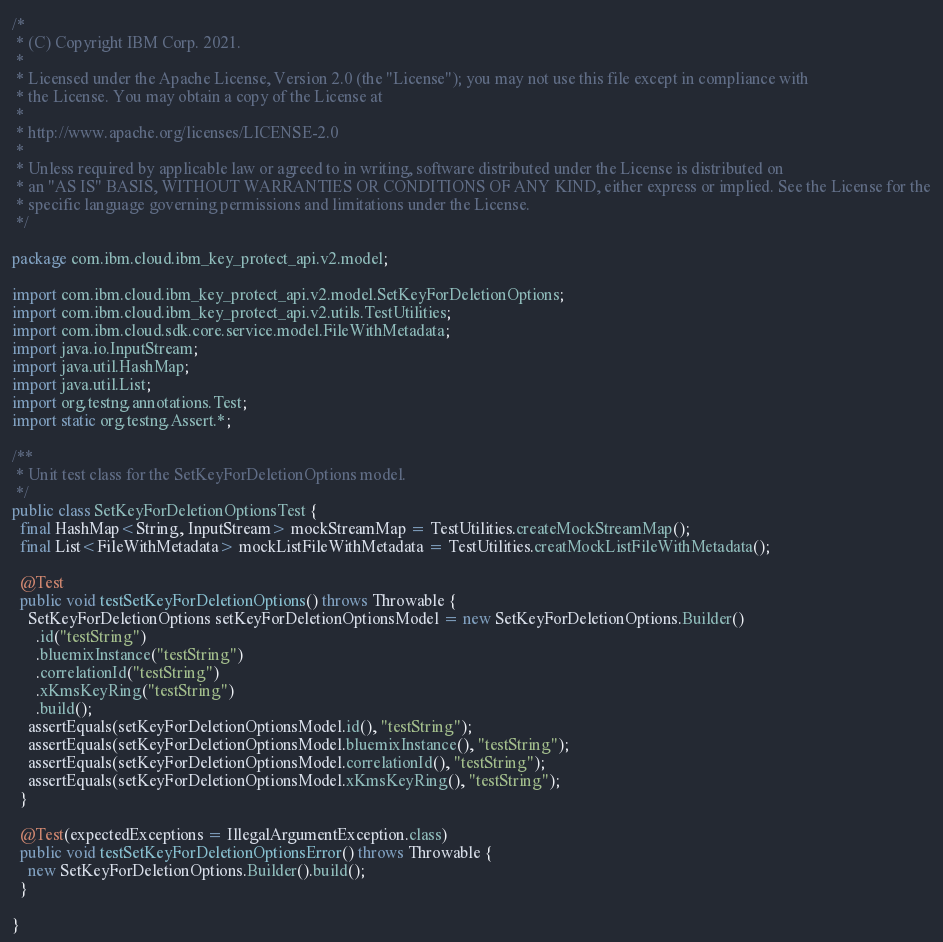<code> <loc_0><loc_0><loc_500><loc_500><_Java_>/*
 * (C) Copyright IBM Corp. 2021.
 *
 * Licensed under the Apache License, Version 2.0 (the "License"); you may not use this file except in compliance with
 * the License. You may obtain a copy of the License at
 *
 * http://www.apache.org/licenses/LICENSE-2.0
 *
 * Unless required by applicable law or agreed to in writing, software distributed under the License is distributed on
 * an "AS IS" BASIS, WITHOUT WARRANTIES OR CONDITIONS OF ANY KIND, either express or implied. See the License for the
 * specific language governing permissions and limitations under the License.
 */

package com.ibm.cloud.ibm_key_protect_api.v2.model;

import com.ibm.cloud.ibm_key_protect_api.v2.model.SetKeyForDeletionOptions;
import com.ibm.cloud.ibm_key_protect_api.v2.utils.TestUtilities;
import com.ibm.cloud.sdk.core.service.model.FileWithMetadata;
import java.io.InputStream;
import java.util.HashMap;
import java.util.List;
import org.testng.annotations.Test;
import static org.testng.Assert.*;

/**
 * Unit test class for the SetKeyForDeletionOptions model.
 */
public class SetKeyForDeletionOptionsTest {
  final HashMap<String, InputStream> mockStreamMap = TestUtilities.createMockStreamMap();
  final List<FileWithMetadata> mockListFileWithMetadata = TestUtilities.creatMockListFileWithMetadata();

  @Test
  public void testSetKeyForDeletionOptions() throws Throwable {
    SetKeyForDeletionOptions setKeyForDeletionOptionsModel = new SetKeyForDeletionOptions.Builder()
      .id("testString")
      .bluemixInstance("testString")
      .correlationId("testString")
      .xKmsKeyRing("testString")
      .build();
    assertEquals(setKeyForDeletionOptionsModel.id(), "testString");
    assertEquals(setKeyForDeletionOptionsModel.bluemixInstance(), "testString");
    assertEquals(setKeyForDeletionOptionsModel.correlationId(), "testString");
    assertEquals(setKeyForDeletionOptionsModel.xKmsKeyRing(), "testString");
  }

  @Test(expectedExceptions = IllegalArgumentException.class)
  public void testSetKeyForDeletionOptionsError() throws Throwable {
    new SetKeyForDeletionOptions.Builder().build();
  }

}</code> 